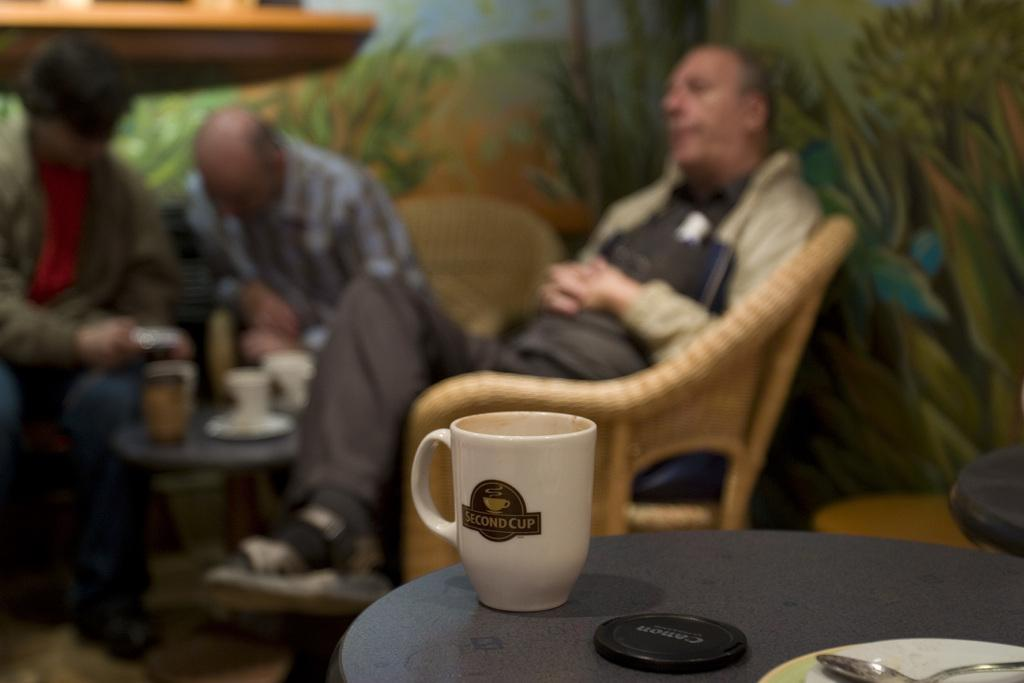What object is placed on the table in the image? There is a coffee cup on the table in the image. What other item can be seen in the image besides the coffee cup? There is a lens cap in the image. How many people are sitting in the background of the image? There are three persons sitting in the background. What are the persons sitting on? The persons are sitting on chairs. Can you see a crown on any of the persons in the image? There is no crown visible on any of the persons in the image. What type of attraction is present in the image? There is no attraction present in the image; it features a coffee cup, a lens cap, and three persons sitting on chairs. 